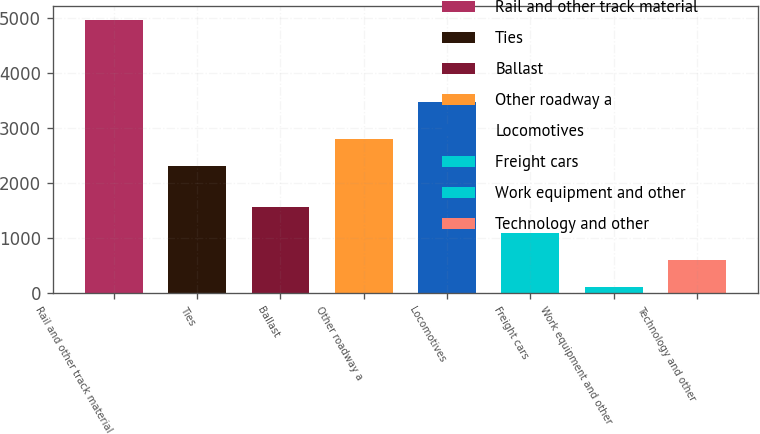Convert chart. <chart><loc_0><loc_0><loc_500><loc_500><bar_chart><fcel>Rail and other track material<fcel>Ties<fcel>Ballast<fcel>Other roadway a<fcel>Locomotives<fcel>Freight cars<fcel>Work equipment and other<fcel>Technology and other<nl><fcel>4970<fcel>2310<fcel>1574.3<fcel>2795.1<fcel>3481<fcel>1089.2<fcel>119<fcel>604.1<nl></chart> 